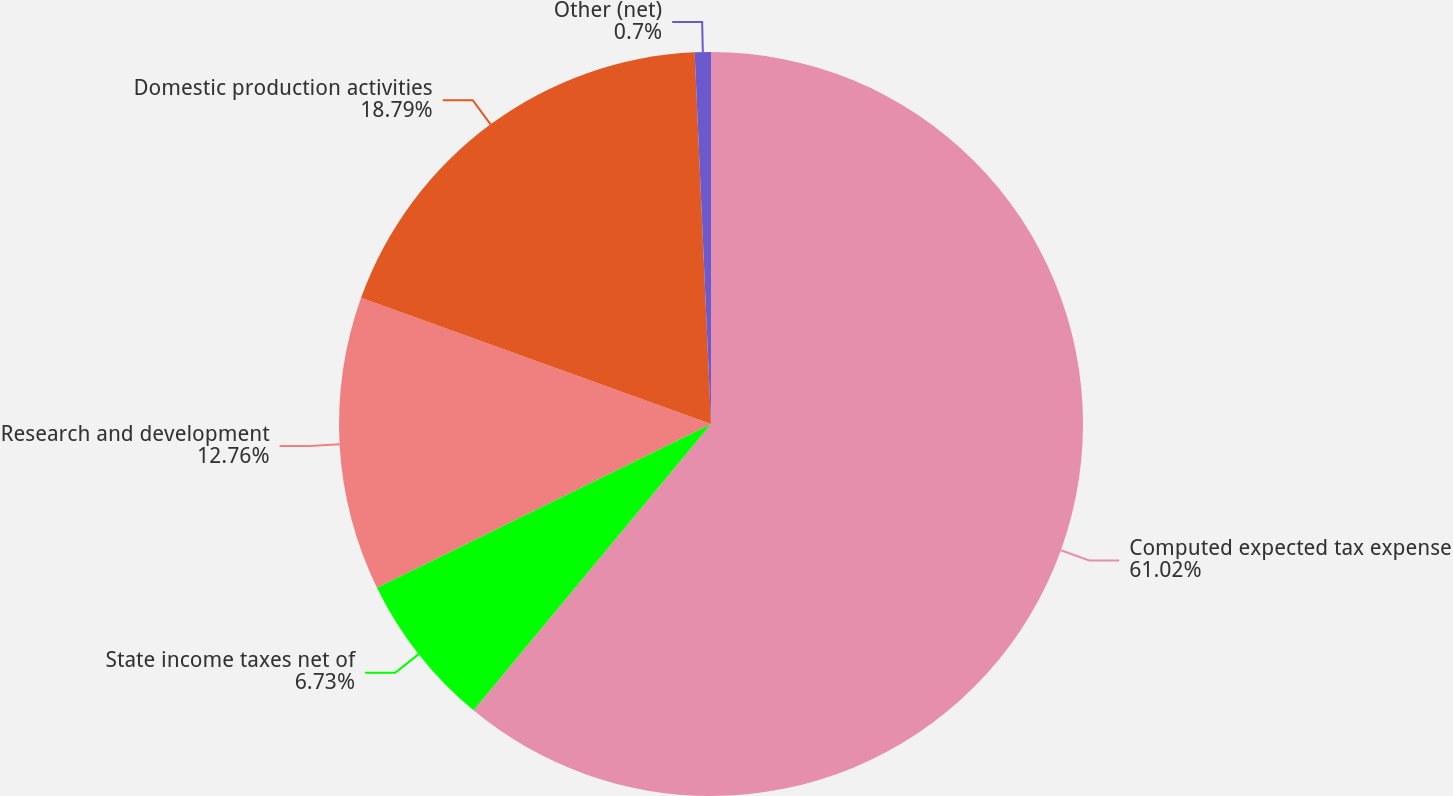Convert chart to OTSL. <chart><loc_0><loc_0><loc_500><loc_500><pie_chart><fcel>Computed expected tax expense<fcel>State income taxes net of<fcel>Research and development<fcel>Domestic production activities<fcel>Other (net)<nl><fcel>61.02%<fcel>6.73%<fcel>12.76%<fcel>18.79%<fcel>0.7%<nl></chart> 